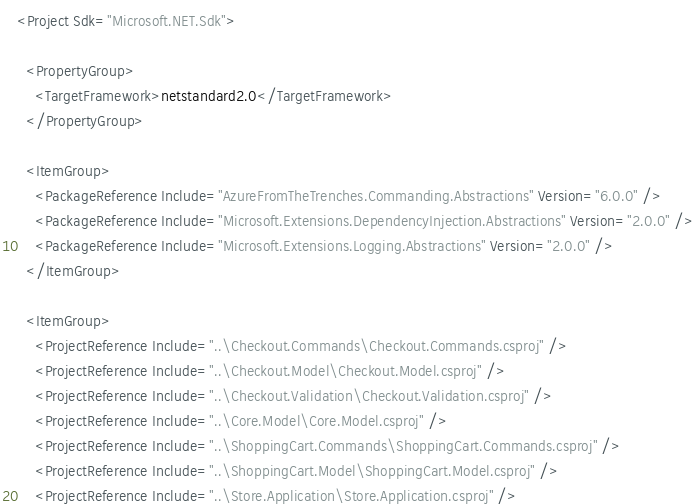Convert code to text. <code><loc_0><loc_0><loc_500><loc_500><_XML_><Project Sdk="Microsoft.NET.Sdk">

  <PropertyGroup>
    <TargetFramework>netstandard2.0</TargetFramework>
  </PropertyGroup>

  <ItemGroup>
    <PackageReference Include="AzureFromTheTrenches.Commanding.Abstractions" Version="6.0.0" />
    <PackageReference Include="Microsoft.Extensions.DependencyInjection.Abstractions" Version="2.0.0" />
    <PackageReference Include="Microsoft.Extensions.Logging.Abstractions" Version="2.0.0" />
  </ItemGroup>

  <ItemGroup>
    <ProjectReference Include="..\Checkout.Commands\Checkout.Commands.csproj" />
    <ProjectReference Include="..\Checkout.Model\Checkout.Model.csproj" />
    <ProjectReference Include="..\Checkout.Validation\Checkout.Validation.csproj" />
    <ProjectReference Include="..\Core.Model\Core.Model.csproj" />
    <ProjectReference Include="..\ShoppingCart.Commands\ShoppingCart.Commands.csproj" />
    <ProjectReference Include="..\ShoppingCart.Model\ShoppingCart.Model.csproj" />
    <ProjectReference Include="..\Store.Application\Store.Application.csproj" /></code> 